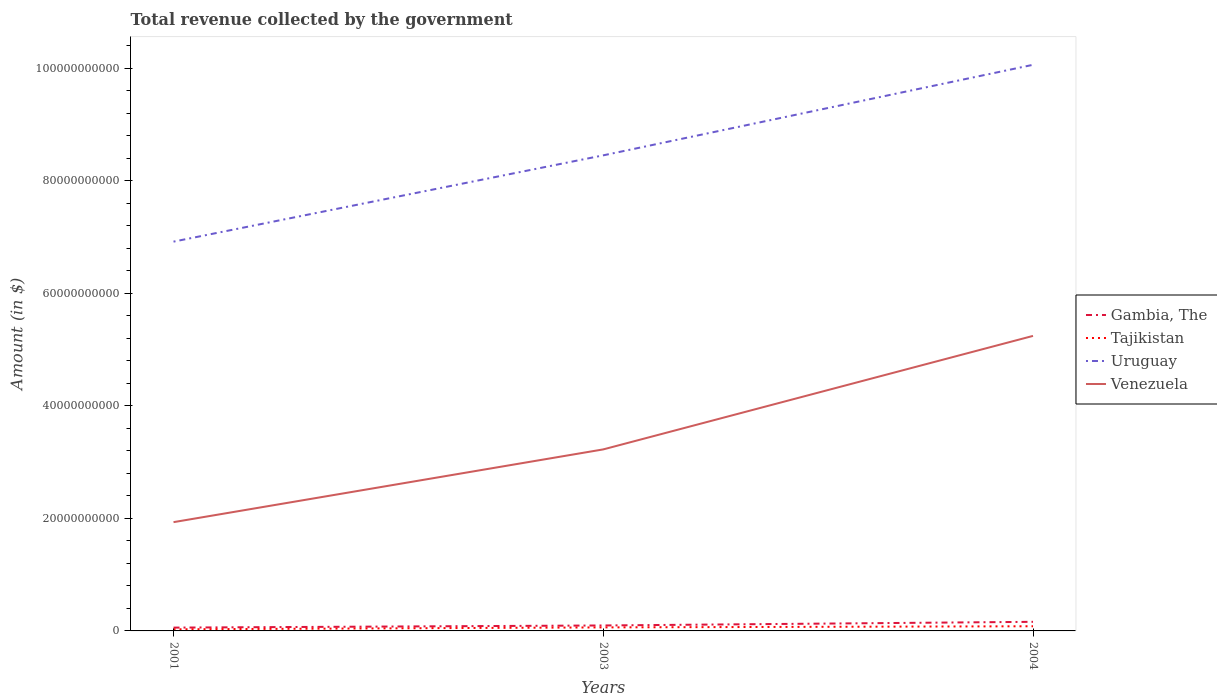How many different coloured lines are there?
Ensure brevity in your answer.  4. Does the line corresponding to Gambia, The intersect with the line corresponding to Venezuela?
Offer a very short reply. No. Across all years, what is the maximum total revenue collected by the government in Tajikistan?
Your answer should be compact. 2.89e+08. In which year was the total revenue collected by the government in Uruguay maximum?
Your response must be concise. 2001. What is the total total revenue collected by the government in Tajikistan in the graph?
Give a very brief answer. -5.41e+08. What is the difference between the highest and the second highest total revenue collected by the government in Uruguay?
Make the answer very short. 3.14e+1. What is the difference between the highest and the lowest total revenue collected by the government in Gambia, The?
Provide a succinct answer. 1. How many lines are there?
Offer a very short reply. 4. What is the difference between two consecutive major ticks on the Y-axis?
Your response must be concise. 2.00e+1. Are the values on the major ticks of Y-axis written in scientific E-notation?
Keep it short and to the point. No. How many legend labels are there?
Your answer should be compact. 4. What is the title of the graph?
Offer a very short reply. Total revenue collected by the government. What is the label or title of the X-axis?
Offer a terse response. Years. What is the label or title of the Y-axis?
Provide a succinct answer. Amount (in $). What is the Amount (in $) of Gambia, The in 2001?
Provide a short and direct response. 5.89e+08. What is the Amount (in $) of Tajikistan in 2001?
Give a very brief answer. 2.89e+08. What is the Amount (in $) of Uruguay in 2001?
Provide a short and direct response. 6.92e+1. What is the Amount (in $) of Venezuela in 2001?
Provide a succinct answer. 1.93e+1. What is the Amount (in $) of Gambia, The in 2003?
Keep it short and to the point. 9.69e+08. What is the Amount (in $) in Tajikistan in 2003?
Keep it short and to the point. 6.26e+08. What is the Amount (in $) in Uruguay in 2003?
Offer a terse response. 8.45e+1. What is the Amount (in $) in Venezuela in 2003?
Provide a short and direct response. 3.23e+1. What is the Amount (in $) of Gambia, The in 2004?
Offer a very short reply. 1.62e+09. What is the Amount (in $) in Tajikistan in 2004?
Provide a succinct answer. 8.30e+08. What is the Amount (in $) of Uruguay in 2004?
Provide a succinct answer. 1.01e+11. What is the Amount (in $) in Venezuela in 2004?
Offer a very short reply. 5.24e+1. Across all years, what is the maximum Amount (in $) of Gambia, The?
Provide a short and direct response. 1.62e+09. Across all years, what is the maximum Amount (in $) in Tajikistan?
Give a very brief answer. 8.30e+08. Across all years, what is the maximum Amount (in $) of Uruguay?
Ensure brevity in your answer.  1.01e+11. Across all years, what is the maximum Amount (in $) in Venezuela?
Keep it short and to the point. 5.24e+1. Across all years, what is the minimum Amount (in $) of Gambia, The?
Provide a succinct answer. 5.89e+08. Across all years, what is the minimum Amount (in $) of Tajikistan?
Your answer should be compact. 2.89e+08. Across all years, what is the minimum Amount (in $) of Uruguay?
Offer a very short reply. 6.92e+1. Across all years, what is the minimum Amount (in $) in Venezuela?
Your answer should be compact. 1.93e+1. What is the total Amount (in $) in Gambia, The in the graph?
Keep it short and to the point. 3.18e+09. What is the total Amount (in $) in Tajikistan in the graph?
Your answer should be very brief. 1.74e+09. What is the total Amount (in $) in Uruguay in the graph?
Give a very brief answer. 2.54e+11. What is the total Amount (in $) in Venezuela in the graph?
Your answer should be very brief. 1.04e+11. What is the difference between the Amount (in $) in Gambia, The in 2001 and that in 2003?
Offer a terse response. -3.80e+08. What is the difference between the Amount (in $) in Tajikistan in 2001 and that in 2003?
Provide a succinct answer. -3.38e+08. What is the difference between the Amount (in $) in Uruguay in 2001 and that in 2003?
Give a very brief answer. -1.53e+1. What is the difference between the Amount (in $) of Venezuela in 2001 and that in 2003?
Ensure brevity in your answer.  -1.29e+1. What is the difference between the Amount (in $) of Gambia, The in 2001 and that in 2004?
Provide a short and direct response. -1.03e+09. What is the difference between the Amount (in $) in Tajikistan in 2001 and that in 2004?
Offer a terse response. -5.41e+08. What is the difference between the Amount (in $) of Uruguay in 2001 and that in 2004?
Your answer should be very brief. -3.14e+1. What is the difference between the Amount (in $) of Venezuela in 2001 and that in 2004?
Provide a short and direct response. -3.31e+1. What is the difference between the Amount (in $) in Gambia, The in 2003 and that in 2004?
Offer a very short reply. -6.48e+08. What is the difference between the Amount (in $) of Tajikistan in 2003 and that in 2004?
Ensure brevity in your answer.  -2.03e+08. What is the difference between the Amount (in $) in Uruguay in 2003 and that in 2004?
Make the answer very short. -1.61e+1. What is the difference between the Amount (in $) in Venezuela in 2003 and that in 2004?
Your response must be concise. -2.02e+1. What is the difference between the Amount (in $) in Gambia, The in 2001 and the Amount (in $) in Tajikistan in 2003?
Keep it short and to the point. -3.71e+07. What is the difference between the Amount (in $) of Gambia, The in 2001 and the Amount (in $) of Uruguay in 2003?
Make the answer very short. -8.39e+1. What is the difference between the Amount (in $) in Gambia, The in 2001 and the Amount (in $) in Venezuela in 2003?
Provide a short and direct response. -3.17e+1. What is the difference between the Amount (in $) of Tajikistan in 2001 and the Amount (in $) of Uruguay in 2003?
Give a very brief answer. -8.42e+1. What is the difference between the Amount (in $) of Tajikistan in 2001 and the Amount (in $) of Venezuela in 2003?
Offer a very short reply. -3.20e+1. What is the difference between the Amount (in $) of Uruguay in 2001 and the Amount (in $) of Venezuela in 2003?
Provide a short and direct response. 3.69e+1. What is the difference between the Amount (in $) in Gambia, The in 2001 and the Amount (in $) in Tajikistan in 2004?
Give a very brief answer. -2.40e+08. What is the difference between the Amount (in $) of Gambia, The in 2001 and the Amount (in $) of Uruguay in 2004?
Make the answer very short. -1.00e+11. What is the difference between the Amount (in $) of Gambia, The in 2001 and the Amount (in $) of Venezuela in 2004?
Offer a very short reply. -5.18e+1. What is the difference between the Amount (in $) in Tajikistan in 2001 and the Amount (in $) in Uruguay in 2004?
Provide a succinct answer. -1.00e+11. What is the difference between the Amount (in $) of Tajikistan in 2001 and the Amount (in $) of Venezuela in 2004?
Offer a terse response. -5.21e+1. What is the difference between the Amount (in $) of Uruguay in 2001 and the Amount (in $) of Venezuela in 2004?
Offer a very short reply. 1.67e+1. What is the difference between the Amount (in $) of Gambia, The in 2003 and the Amount (in $) of Tajikistan in 2004?
Your answer should be compact. 1.40e+08. What is the difference between the Amount (in $) of Gambia, The in 2003 and the Amount (in $) of Uruguay in 2004?
Your answer should be compact. -9.96e+1. What is the difference between the Amount (in $) in Gambia, The in 2003 and the Amount (in $) in Venezuela in 2004?
Your response must be concise. -5.15e+1. What is the difference between the Amount (in $) in Tajikistan in 2003 and the Amount (in $) in Uruguay in 2004?
Offer a terse response. -1.00e+11. What is the difference between the Amount (in $) in Tajikistan in 2003 and the Amount (in $) in Venezuela in 2004?
Make the answer very short. -5.18e+1. What is the difference between the Amount (in $) of Uruguay in 2003 and the Amount (in $) of Venezuela in 2004?
Give a very brief answer. 3.21e+1. What is the average Amount (in $) in Gambia, The per year?
Make the answer very short. 1.06e+09. What is the average Amount (in $) of Tajikistan per year?
Your answer should be compact. 5.82e+08. What is the average Amount (in $) in Uruguay per year?
Ensure brevity in your answer.  8.48e+1. What is the average Amount (in $) in Venezuela per year?
Keep it short and to the point. 3.47e+1. In the year 2001, what is the difference between the Amount (in $) of Gambia, The and Amount (in $) of Tajikistan?
Provide a short and direct response. 3.01e+08. In the year 2001, what is the difference between the Amount (in $) in Gambia, The and Amount (in $) in Uruguay?
Your response must be concise. -6.86e+1. In the year 2001, what is the difference between the Amount (in $) of Gambia, The and Amount (in $) of Venezuela?
Your answer should be compact. -1.87e+1. In the year 2001, what is the difference between the Amount (in $) in Tajikistan and Amount (in $) in Uruguay?
Give a very brief answer. -6.89e+1. In the year 2001, what is the difference between the Amount (in $) of Tajikistan and Amount (in $) of Venezuela?
Your answer should be compact. -1.90e+1. In the year 2001, what is the difference between the Amount (in $) in Uruguay and Amount (in $) in Venezuela?
Offer a very short reply. 4.98e+1. In the year 2003, what is the difference between the Amount (in $) in Gambia, The and Amount (in $) in Tajikistan?
Ensure brevity in your answer.  3.43e+08. In the year 2003, what is the difference between the Amount (in $) of Gambia, The and Amount (in $) of Uruguay?
Ensure brevity in your answer.  -8.35e+1. In the year 2003, what is the difference between the Amount (in $) of Gambia, The and Amount (in $) of Venezuela?
Ensure brevity in your answer.  -3.13e+1. In the year 2003, what is the difference between the Amount (in $) in Tajikistan and Amount (in $) in Uruguay?
Keep it short and to the point. -8.39e+1. In the year 2003, what is the difference between the Amount (in $) in Tajikistan and Amount (in $) in Venezuela?
Provide a short and direct response. -3.16e+1. In the year 2003, what is the difference between the Amount (in $) in Uruguay and Amount (in $) in Venezuela?
Keep it short and to the point. 5.22e+1. In the year 2004, what is the difference between the Amount (in $) in Gambia, The and Amount (in $) in Tajikistan?
Make the answer very short. 7.88e+08. In the year 2004, what is the difference between the Amount (in $) of Gambia, The and Amount (in $) of Uruguay?
Offer a very short reply. -9.90e+1. In the year 2004, what is the difference between the Amount (in $) in Gambia, The and Amount (in $) in Venezuela?
Offer a very short reply. -5.08e+1. In the year 2004, what is the difference between the Amount (in $) in Tajikistan and Amount (in $) in Uruguay?
Your response must be concise. -9.98e+1. In the year 2004, what is the difference between the Amount (in $) of Tajikistan and Amount (in $) of Venezuela?
Ensure brevity in your answer.  -5.16e+1. In the year 2004, what is the difference between the Amount (in $) in Uruguay and Amount (in $) in Venezuela?
Provide a succinct answer. 4.82e+1. What is the ratio of the Amount (in $) of Gambia, The in 2001 to that in 2003?
Offer a very short reply. 0.61. What is the ratio of the Amount (in $) in Tajikistan in 2001 to that in 2003?
Provide a succinct answer. 0.46. What is the ratio of the Amount (in $) of Uruguay in 2001 to that in 2003?
Your answer should be very brief. 0.82. What is the ratio of the Amount (in $) in Venezuela in 2001 to that in 2003?
Provide a succinct answer. 0.6. What is the ratio of the Amount (in $) in Gambia, The in 2001 to that in 2004?
Your response must be concise. 0.36. What is the ratio of the Amount (in $) in Tajikistan in 2001 to that in 2004?
Offer a terse response. 0.35. What is the ratio of the Amount (in $) in Uruguay in 2001 to that in 2004?
Your answer should be compact. 0.69. What is the ratio of the Amount (in $) in Venezuela in 2001 to that in 2004?
Keep it short and to the point. 0.37. What is the ratio of the Amount (in $) of Gambia, The in 2003 to that in 2004?
Provide a short and direct response. 0.6. What is the ratio of the Amount (in $) in Tajikistan in 2003 to that in 2004?
Give a very brief answer. 0.76. What is the ratio of the Amount (in $) of Uruguay in 2003 to that in 2004?
Keep it short and to the point. 0.84. What is the ratio of the Amount (in $) of Venezuela in 2003 to that in 2004?
Ensure brevity in your answer.  0.62. What is the difference between the highest and the second highest Amount (in $) in Gambia, The?
Keep it short and to the point. 6.48e+08. What is the difference between the highest and the second highest Amount (in $) of Tajikistan?
Provide a succinct answer. 2.03e+08. What is the difference between the highest and the second highest Amount (in $) of Uruguay?
Offer a terse response. 1.61e+1. What is the difference between the highest and the second highest Amount (in $) in Venezuela?
Give a very brief answer. 2.02e+1. What is the difference between the highest and the lowest Amount (in $) of Gambia, The?
Your answer should be very brief. 1.03e+09. What is the difference between the highest and the lowest Amount (in $) in Tajikistan?
Make the answer very short. 5.41e+08. What is the difference between the highest and the lowest Amount (in $) of Uruguay?
Provide a succinct answer. 3.14e+1. What is the difference between the highest and the lowest Amount (in $) of Venezuela?
Provide a short and direct response. 3.31e+1. 